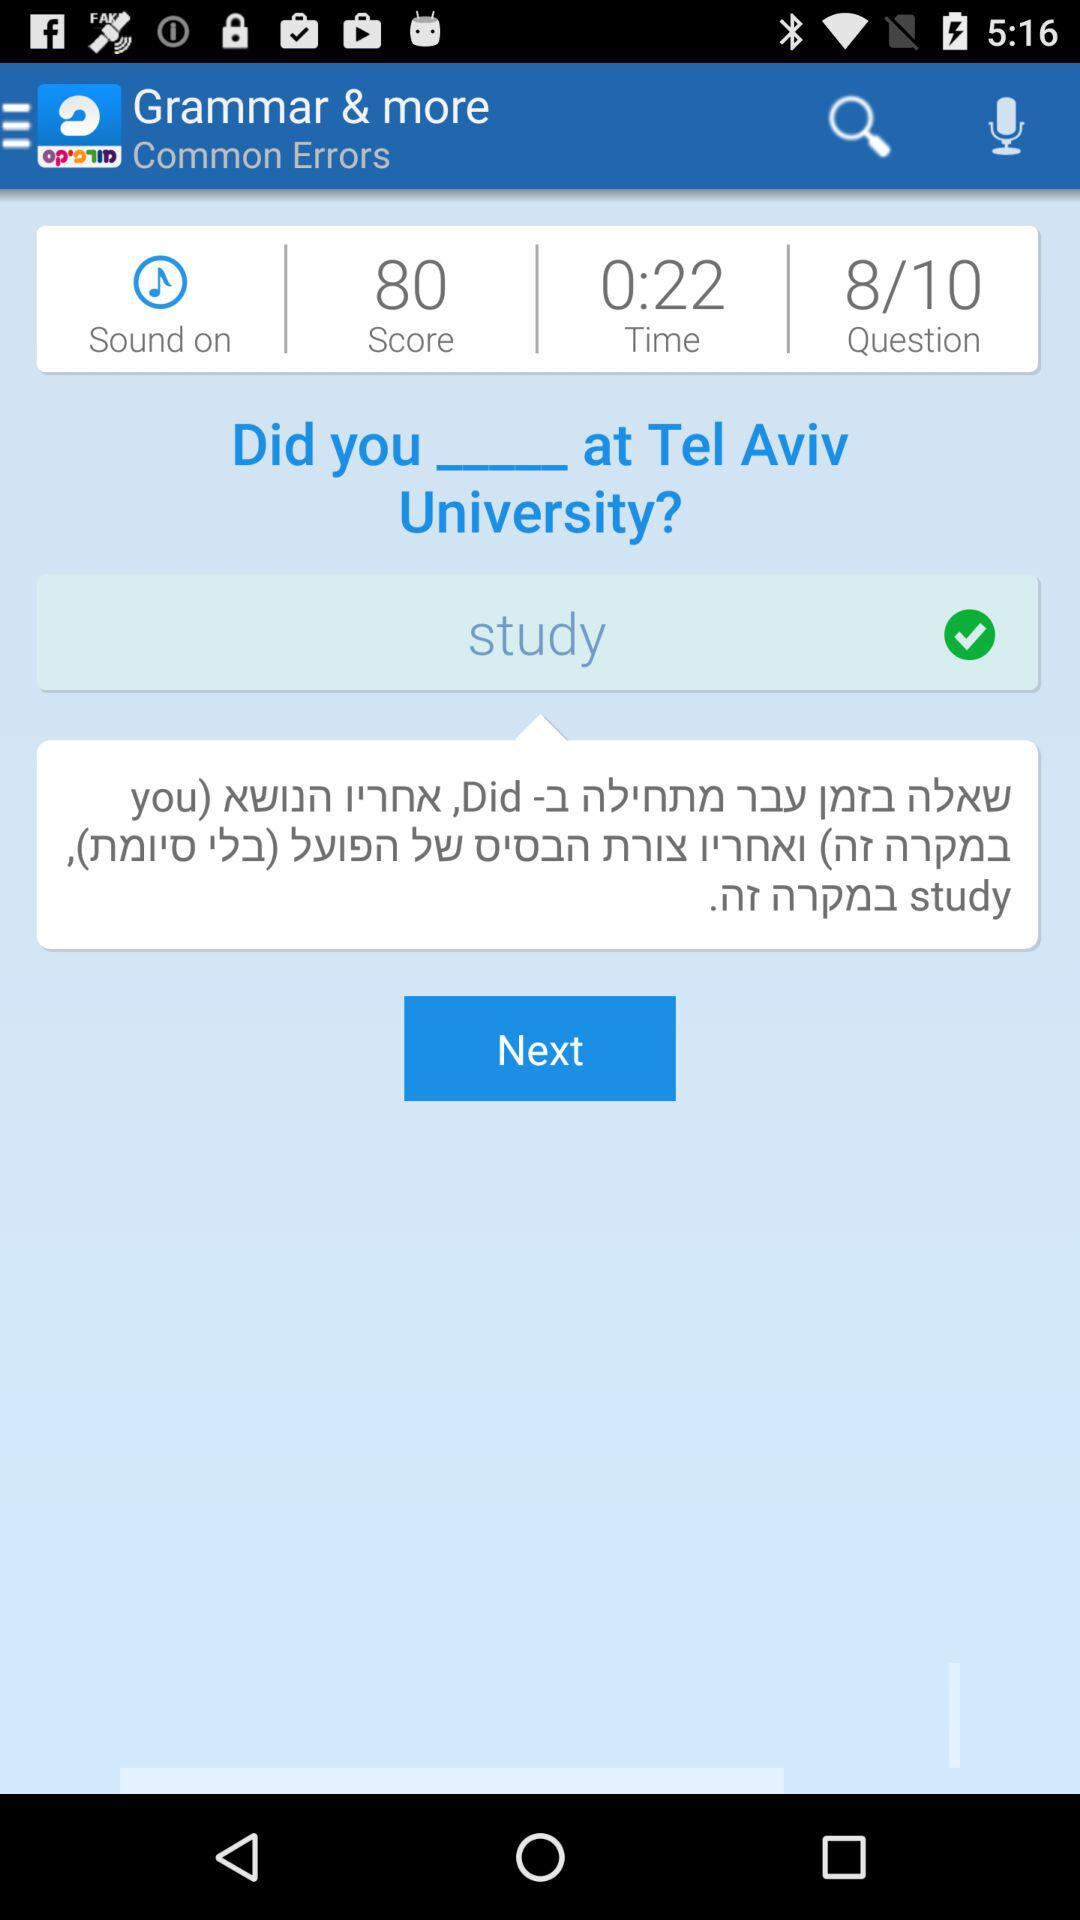How many questions in total are there? There are 10 questions in total. 